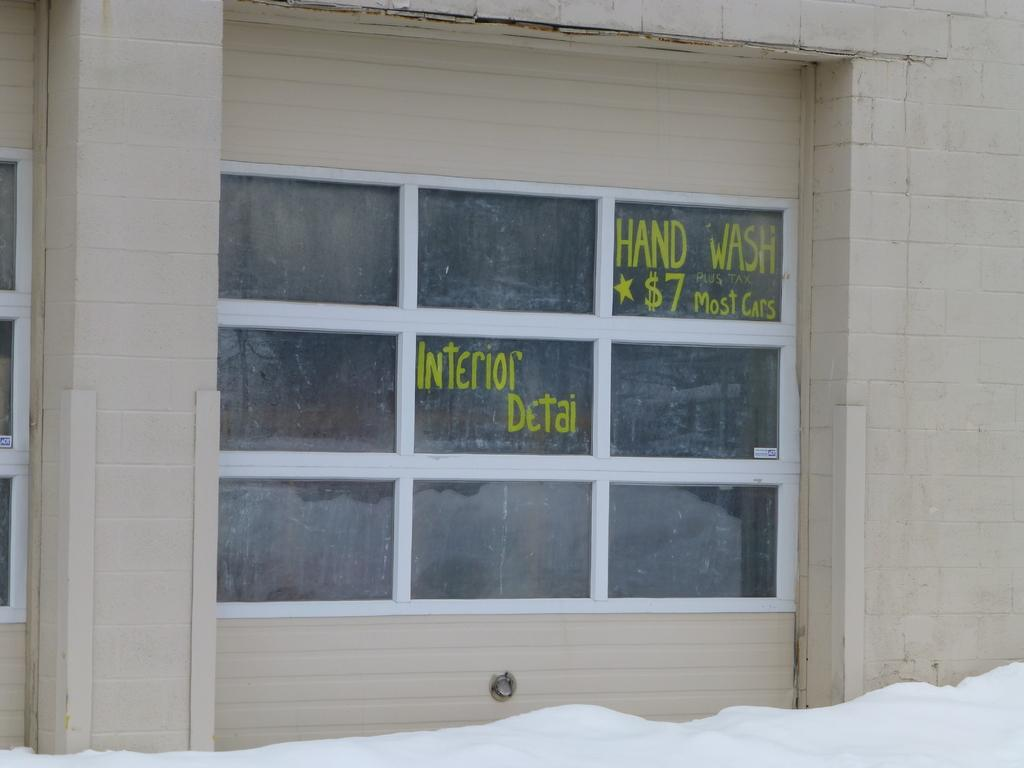What type of surface can be seen in the image? There is a glass window in the image. What is written on the glass window? There is text written on the glass window. What is the condition of the surface outside the window? There is snow on the surface in front of the window. What type of grape is being used for the activity depicted on the glass window? There is no grape or activity involving a grape present in the image. 